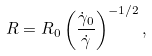Convert formula to latex. <formula><loc_0><loc_0><loc_500><loc_500>R = R _ { 0 } \left ( \frac { \dot { \gamma } _ { 0 } } { \dot { \gamma } } \right ) ^ { - 1 / 2 } ,</formula> 